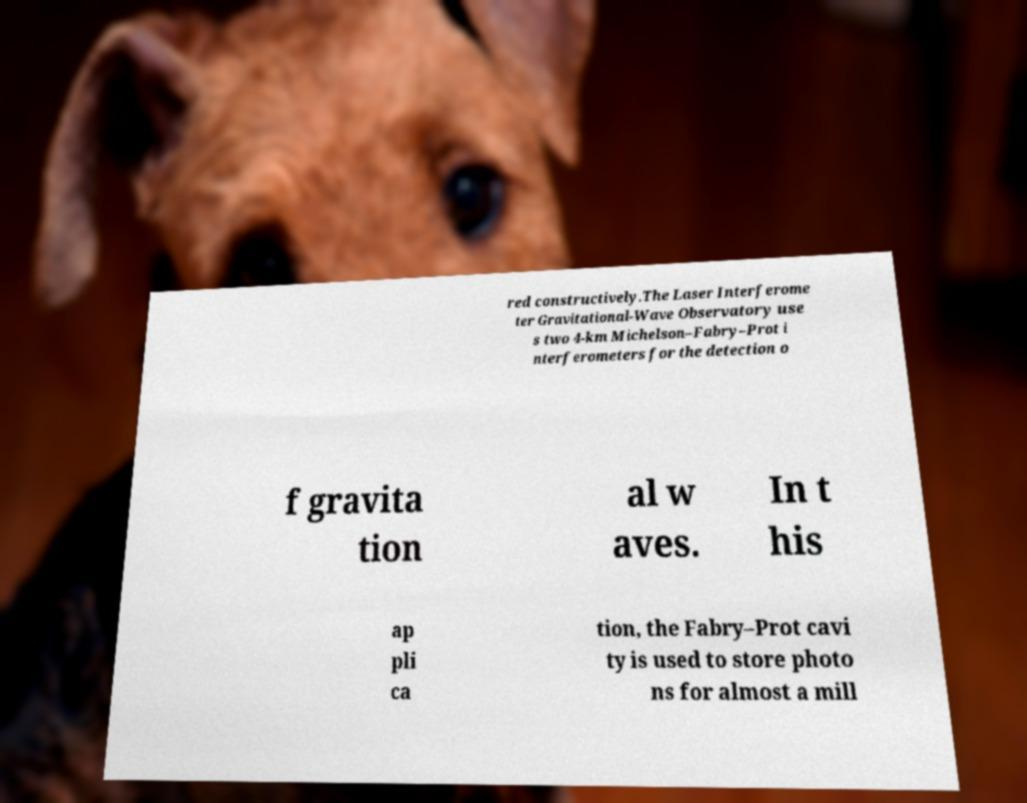Please identify and transcribe the text found in this image. red constructively.The Laser Interferome ter Gravitational-Wave Observatory use s two 4-km Michelson–Fabry–Prot i nterferometers for the detection o f gravita tion al w aves. In t his ap pli ca tion, the Fabry–Prot cavi ty is used to store photo ns for almost a mill 